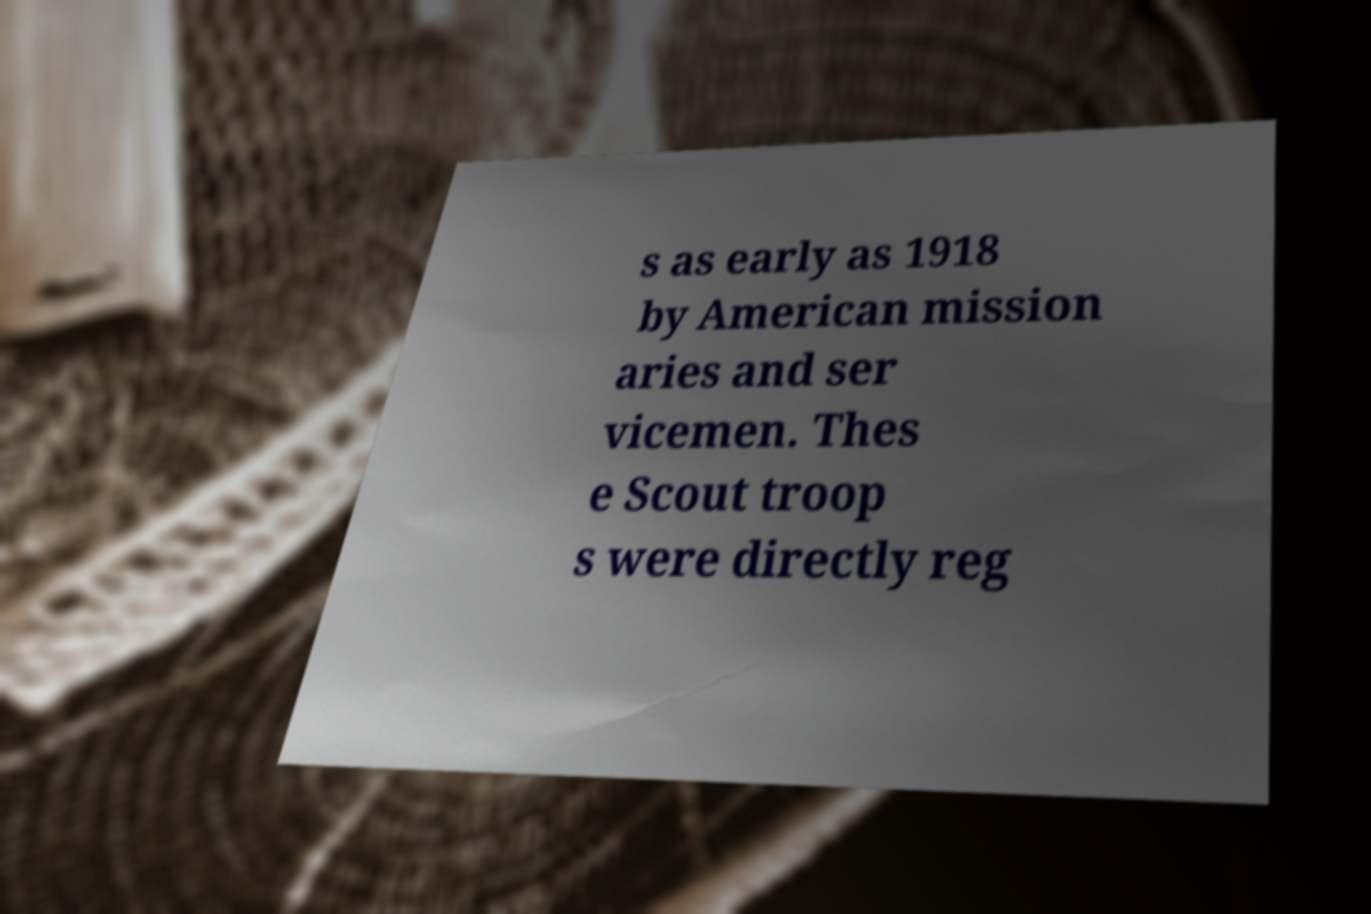Can you accurately transcribe the text from the provided image for me? s as early as 1918 by American mission aries and ser vicemen. Thes e Scout troop s were directly reg 